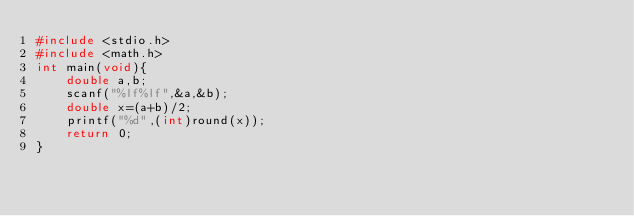Convert code to text. <code><loc_0><loc_0><loc_500><loc_500><_C_>#include <stdio.h>
#include <math.h>
int main(void){
    double a,b;
    scanf("%lf%lf",&a,&b);
    double x=(a+b)/2;
    printf("%d",(int)round(x));
    return 0;
}</code> 